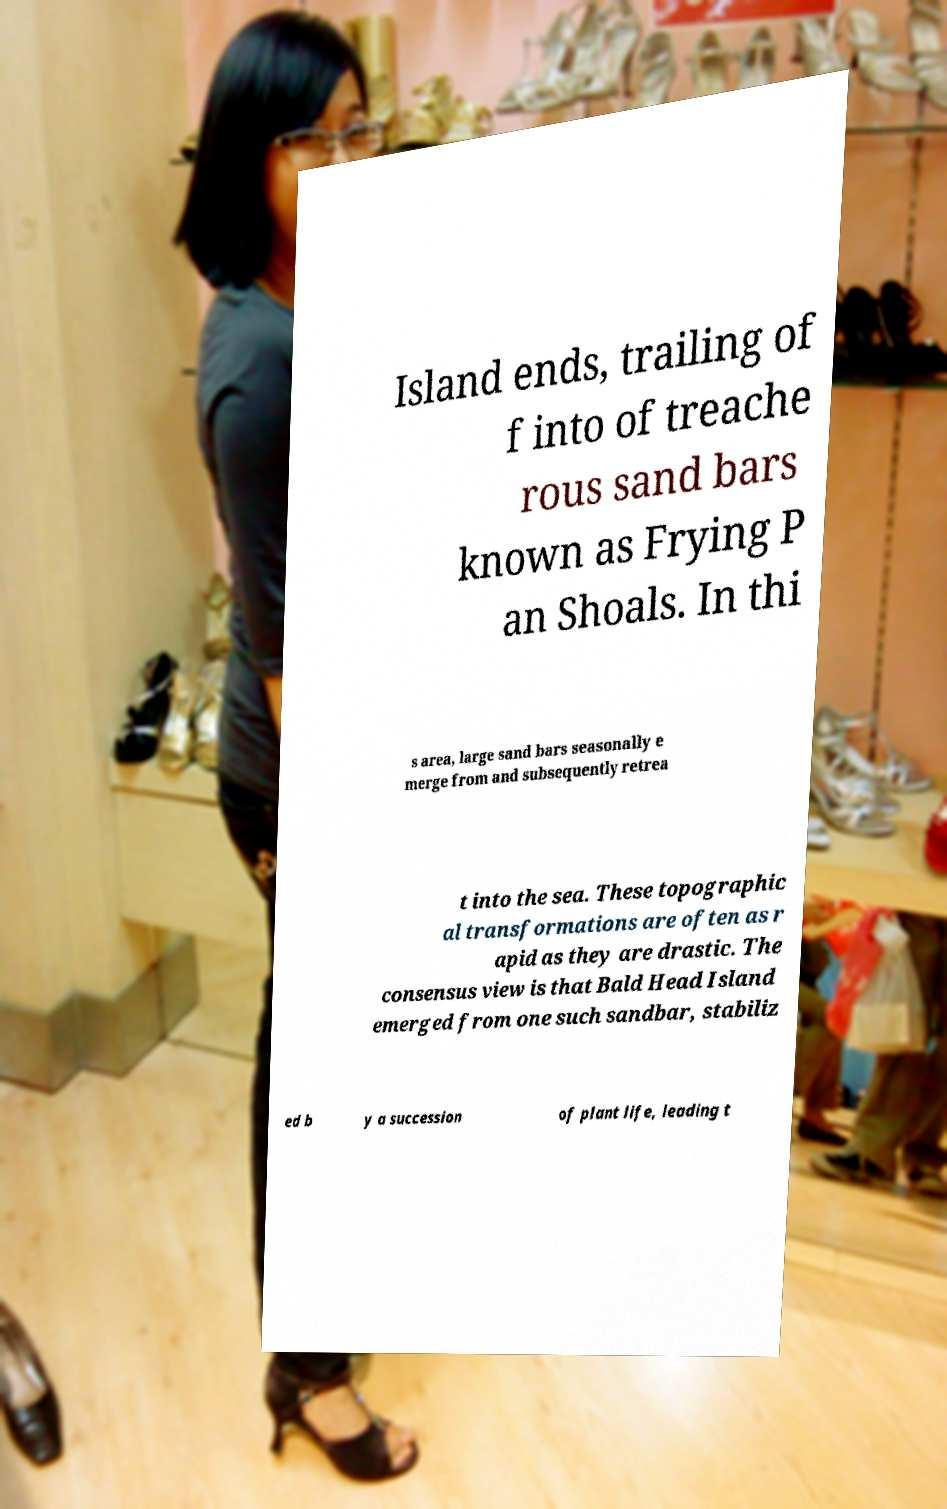There's text embedded in this image that I need extracted. Can you transcribe it verbatim? Island ends, trailing of f into of treache rous sand bars known as Frying P an Shoals. In thi s area, large sand bars seasonally e merge from and subsequently retrea t into the sea. These topographic al transformations are often as r apid as they are drastic. The consensus view is that Bald Head Island emerged from one such sandbar, stabiliz ed b y a succession of plant life, leading t 